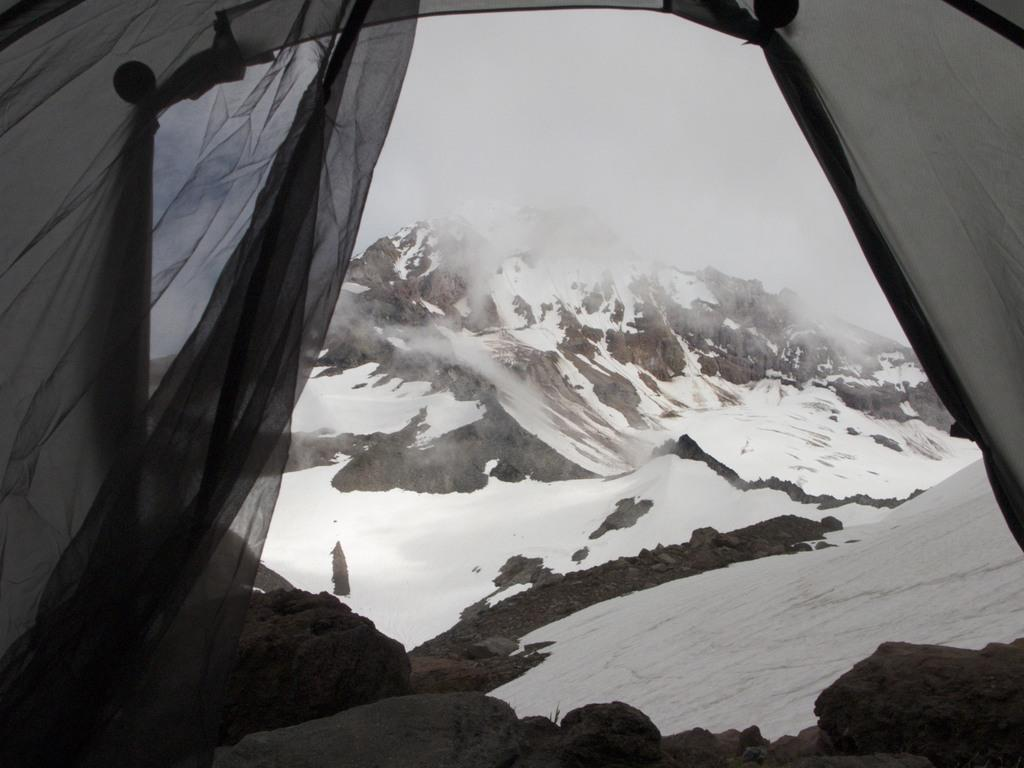What type of structure is visible in the image? The image shows the inside view of a tent. What can be seen in the background of the image? There is snow on the ground, a mountain, and the sky visible in the background. Can you describe the presence of smoke in the image? Yes, there is smoke present in the image. What type of nail is being used to repair the ship in the image? There is no ship or nail present in the image; it shows the inside view of a tent with a mountain and snow in the background. 